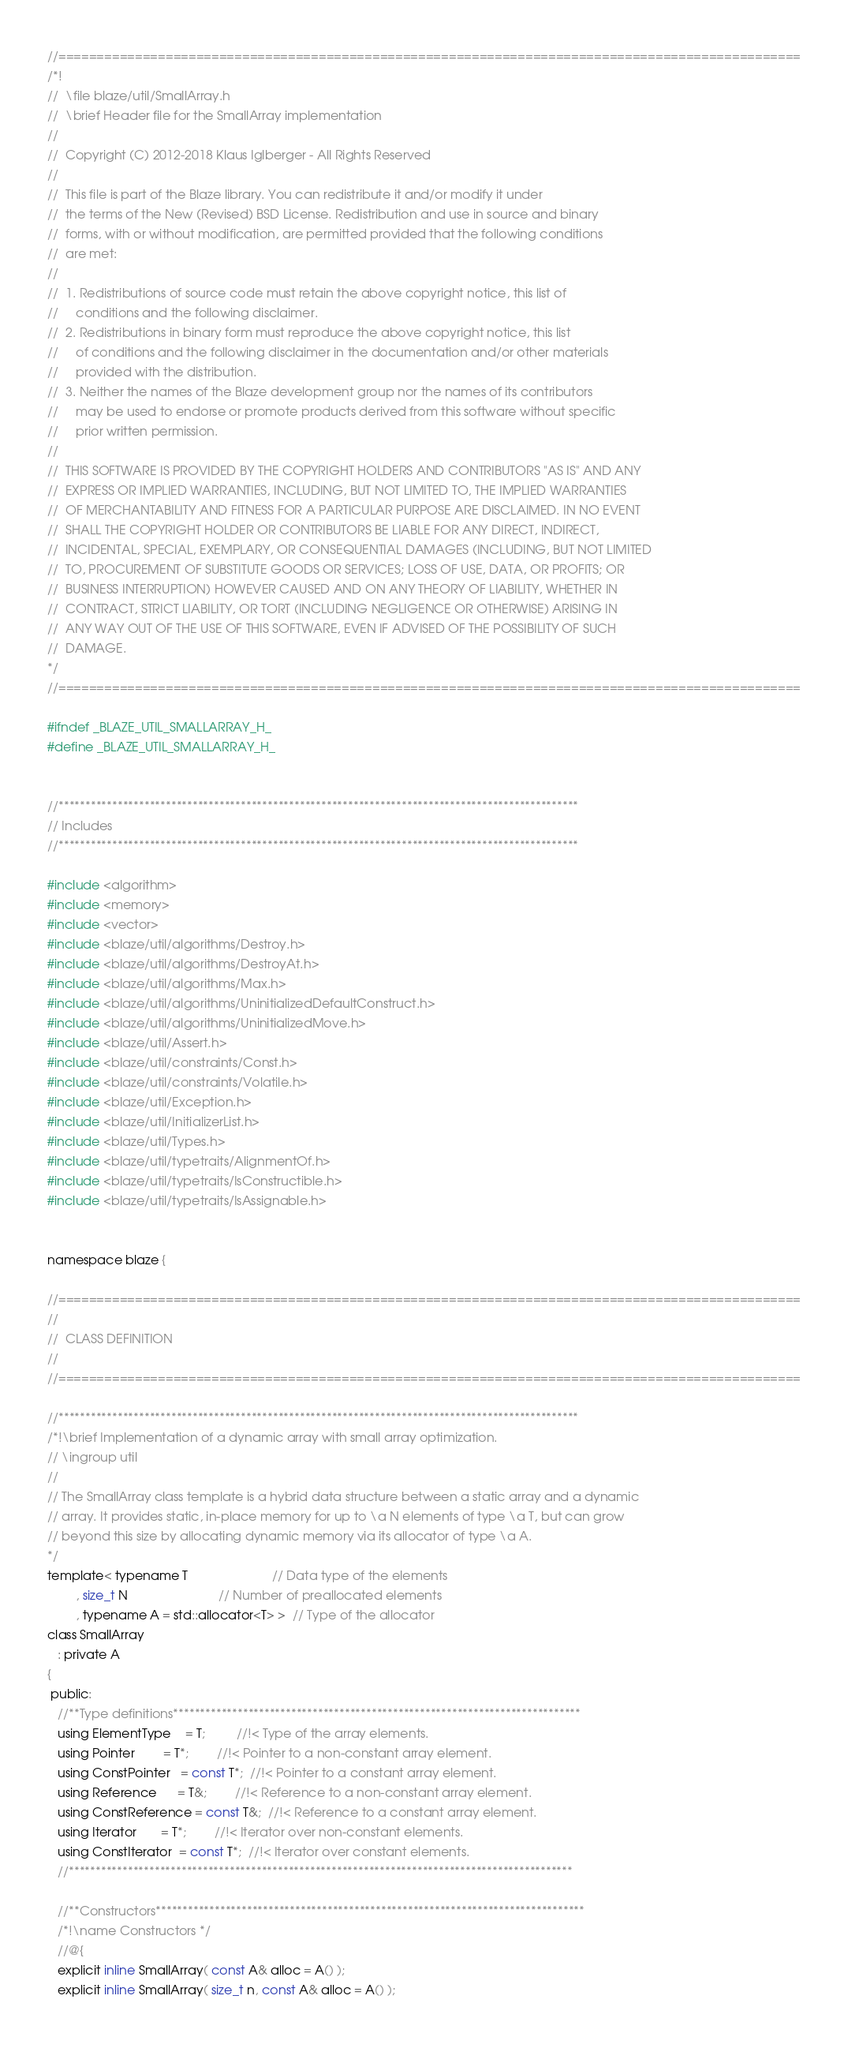<code> <loc_0><loc_0><loc_500><loc_500><_C_>//=================================================================================================
/*!
//  \file blaze/util/SmallArray.h
//  \brief Header file for the SmallArray implementation
//
//  Copyright (C) 2012-2018 Klaus Iglberger - All Rights Reserved
//
//  This file is part of the Blaze library. You can redistribute it and/or modify it under
//  the terms of the New (Revised) BSD License. Redistribution and use in source and binary
//  forms, with or without modification, are permitted provided that the following conditions
//  are met:
//
//  1. Redistributions of source code must retain the above copyright notice, this list of
//     conditions and the following disclaimer.
//  2. Redistributions in binary form must reproduce the above copyright notice, this list
//     of conditions and the following disclaimer in the documentation and/or other materials
//     provided with the distribution.
//  3. Neither the names of the Blaze development group nor the names of its contributors
//     may be used to endorse or promote products derived from this software without specific
//     prior written permission.
//
//  THIS SOFTWARE IS PROVIDED BY THE COPYRIGHT HOLDERS AND CONTRIBUTORS "AS IS" AND ANY
//  EXPRESS OR IMPLIED WARRANTIES, INCLUDING, BUT NOT LIMITED TO, THE IMPLIED WARRANTIES
//  OF MERCHANTABILITY AND FITNESS FOR A PARTICULAR PURPOSE ARE DISCLAIMED. IN NO EVENT
//  SHALL THE COPYRIGHT HOLDER OR CONTRIBUTORS BE LIABLE FOR ANY DIRECT, INDIRECT,
//  INCIDENTAL, SPECIAL, EXEMPLARY, OR CONSEQUENTIAL DAMAGES (INCLUDING, BUT NOT LIMITED
//  TO, PROCUREMENT OF SUBSTITUTE GOODS OR SERVICES; LOSS OF USE, DATA, OR PROFITS; OR
//  BUSINESS INTERRUPTION) HOWEVER CAUSED AND ON ANY THEORY OF LIABILITY, WHETHER IN
//  CONTRACT, STRICT LIABILITY, OR TORT (INCLUDING NEGLIGENCE OR OTHERWISE) ARISING IN
//  ANY WAY OUT OF THE USE OF THIS SOFTWARE, EVEN IF ADVISED OF THE POSSIBILITY OF SUCH
//  DAMAGE.
*/
//=================================================================================================

#ifndef _BLAZE_UTIL_SMALLARRAY_H_
#define _BLAZE_UTIL_SMALLARRAY_H_


//*************************************************************************************************
// Includes
//*************************************************************************************************

#include <algorithm>
#include <memory>
#include <vector>
#include <blaze/util/algorithms/Destroy.h>
#include <blaze/util/algorithms/DestroyAt.h>
#include <blaze/util/algorithms/Max.h>
#include <blaze/util/algorithms/UninitializedDefaultConstruct.h>
#include <blaze/util/algorithms/UninitializedMove.h>
#include <blaze/util/Assert.h>
#include <blaze/util/constraints/Const.h>
#include <blaze/util/constraints/Volatile.h>
#include <blaze/util/Exception.h>
#include <blaze/util/InitializerList.h>
#include <blaze/util/Types.h>
#include <blaze/util/typetraits/AlignmentOf.h>
#include <blaze/util/typetraits/IsConstructible.h>
#include <blaze/util/typetraits/IsAssignable.h>


namespace blaze {

//=================================================================================================
//
//  CLASS DEFINITION
//
//=================================================================================================

//*************************************************************************************************
/*!\brief Implementation of a dynamic array with small array optimization.
// \ingroup util
//
// The SmallArray class template is a hybrid data structure between a static array and a dynamic
// array. It provides static, in-place memory for up to \a N elements of type \a T, but can grow
// beyond this size by allocating dynamic memory via its allocator of type \a A.
*/
template< typename T                        // Data type of the elements
        , size_t N                          // Number of preallocated elements
        , typename A = std::allocator<T> >  // Type of the allocator
class SmallArray
   : private A
{
 public:
   //**Type definitions****************************************************************************
   using ElementType    = T;         //!< Type of the array elements.
   using Pointer        = T*;        //!< Pointer to a non-constant array element.
   using ConstPointer   = const T*;  //!< Pointer to a constant array element.
   using Reference      = T&;        //!< Reference to a non-constant array element.
   using ConstReference = const T&;  //!< Reference to a constant array element.
   using Iterator       = T*;        //!< Iterator over non-constant elements.
   using ConstIterator  = const T*;  //!< Iterator over constant elements.
   //**********************************************************************************************

   //**Constructors********************************************************************************
   /*!\name Constructors */
   //@{
   explicit inline SmallArray( const A& alloc = A() );
   explicit inline SmallArray( size_t n, const A& alloc = A() );</code> 